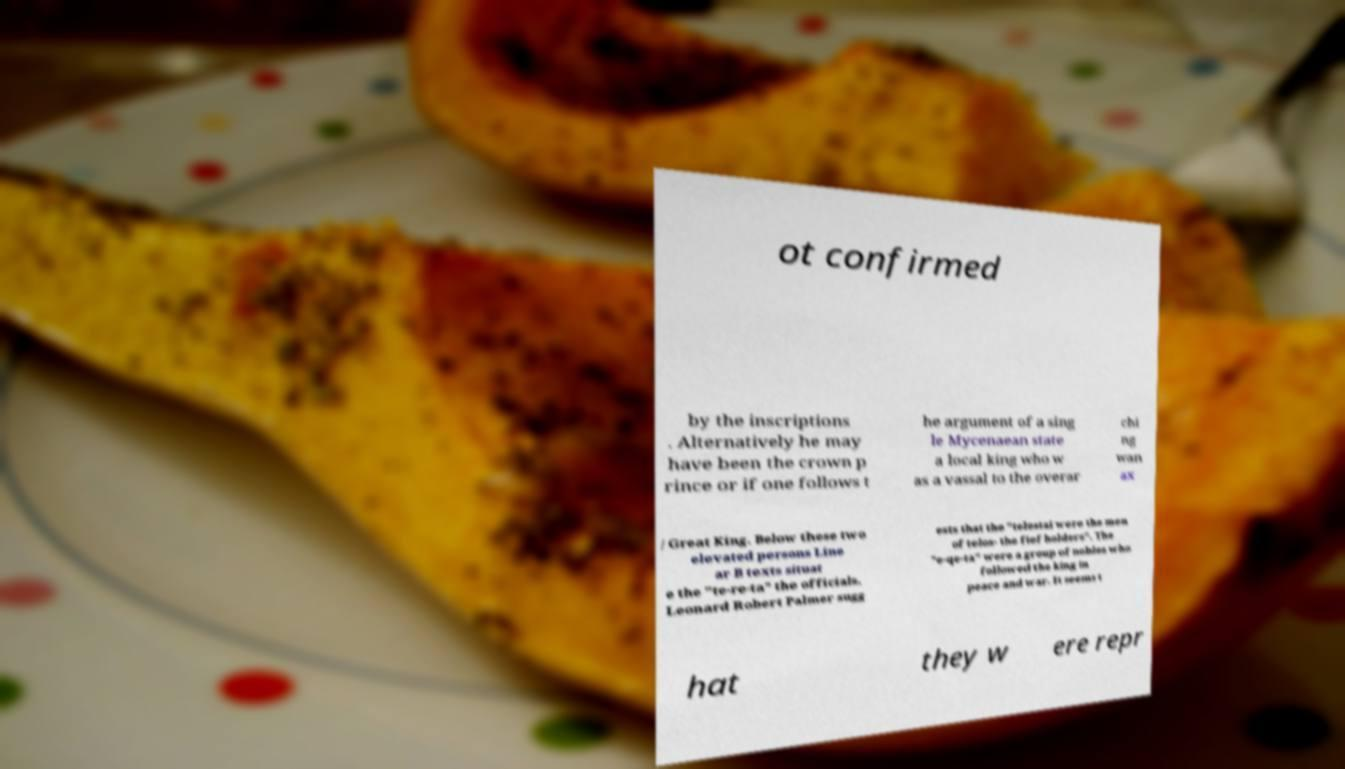I need the written content from this picture converted into text. Can you do that? ot confirmed by the inscriptions . Alternatively he may have been the crown p rince or if one follows t he argument of a sing le Mycenaean state a local king who w as a vassal to the overar chi ng wan ax / Great King. Below these two elevated persons Line ar B texts situat e the "te-re-ta" the officials. Leonard Robert Palmer sugg ests that the "telestai were the men of telos- the fief holders". The "e-qe-ta" were a group of nobles who followed the king in peace and war. It seems t hat they w ere repr 